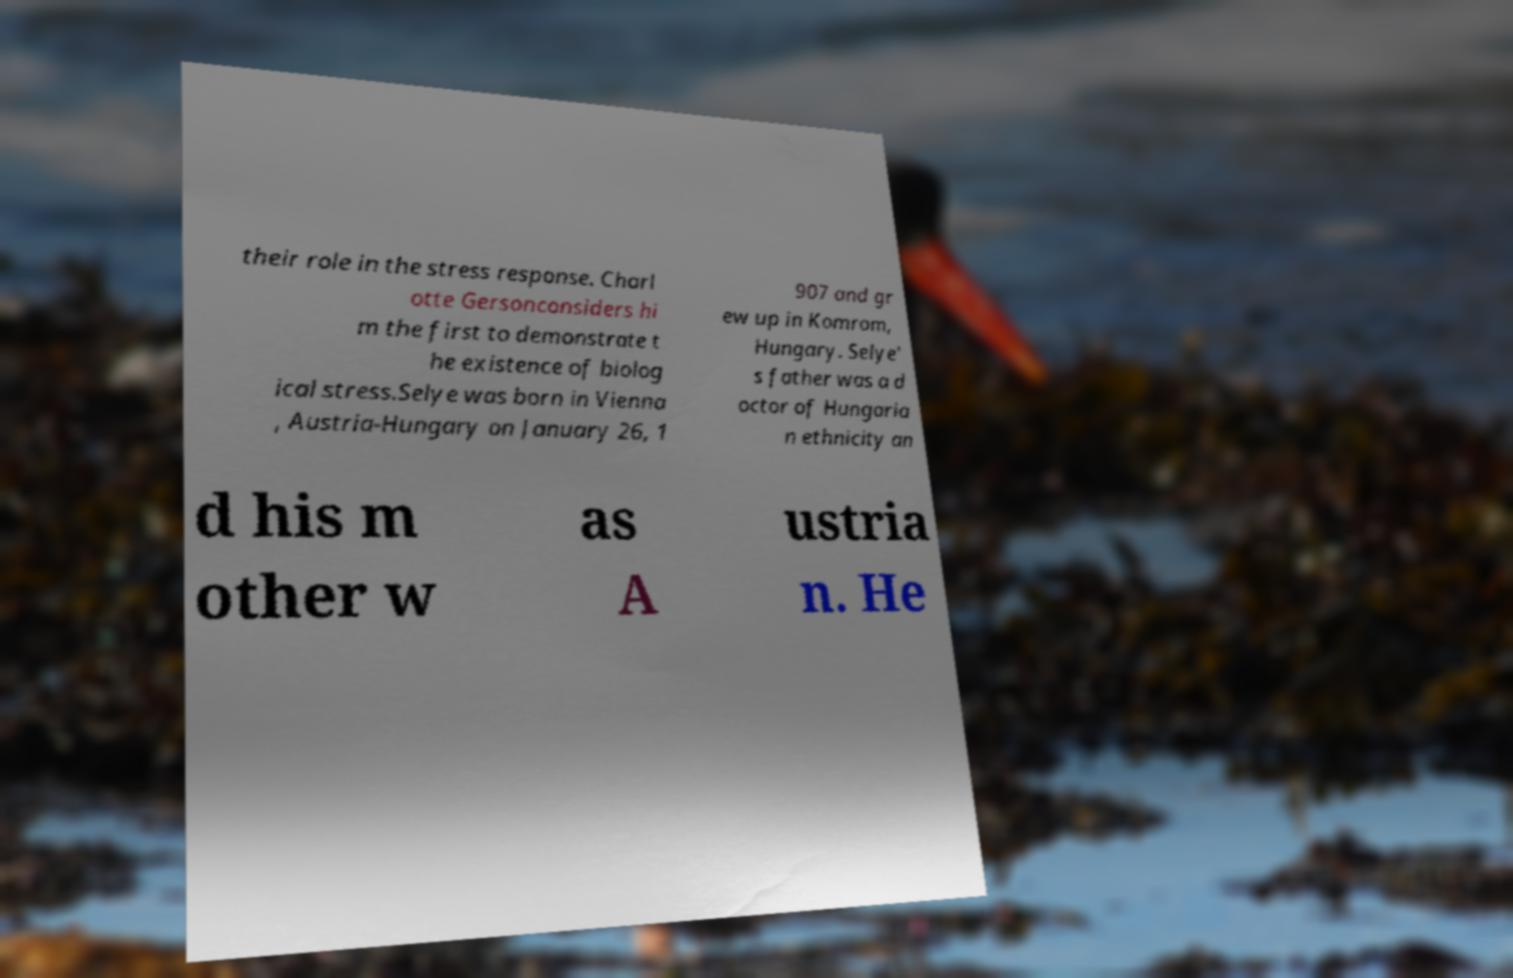There's text embedded in this image that I need extracted. Can you transcribe it verbatim? their role in the stress response. Charl otte Gersonconsiders hi m the first to demonstrate t he existence of biolog ical stress.Selye was born in Vienna , Austria-Hungary on January 26, 1 907 and gr ew up in Komrom, Hungary. Selye' s father was a d octor of Hungaria n ethnicity an d his m other w as A ustria n. He 